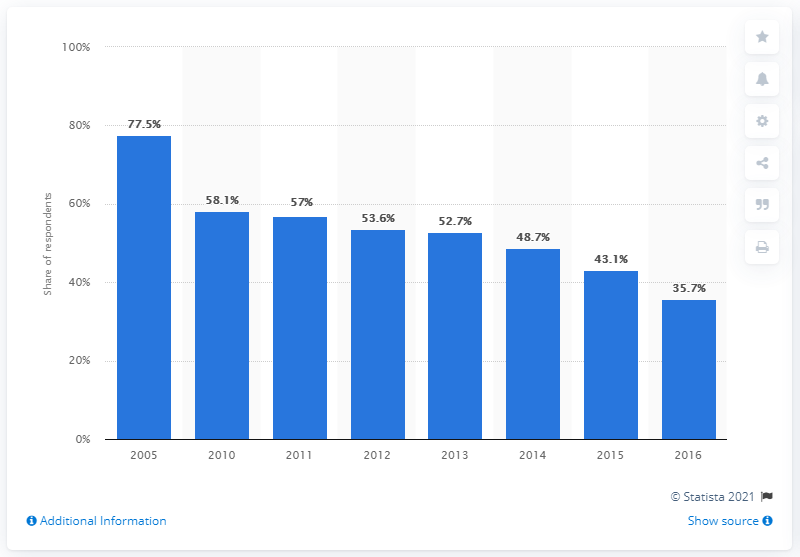Identify some key points in this picture. In 2016, a significant percentage of school children read magazines outside of class, with 35.7% reporting that they regularly engaged in this activity. 